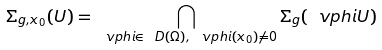Convert formula to latex. <formula><loc_0><loc_0><loc_500><loc_500>\Sigma _ { g , x _ { 0 } } ( U ) = \bigcap _ { \ v p h i \in \ D ( \Omega ) , \, \ v p h i ( x _ { 0 } ) \not = 0 } \Sigma _ { g } ( \ v p h i U )</formula> 